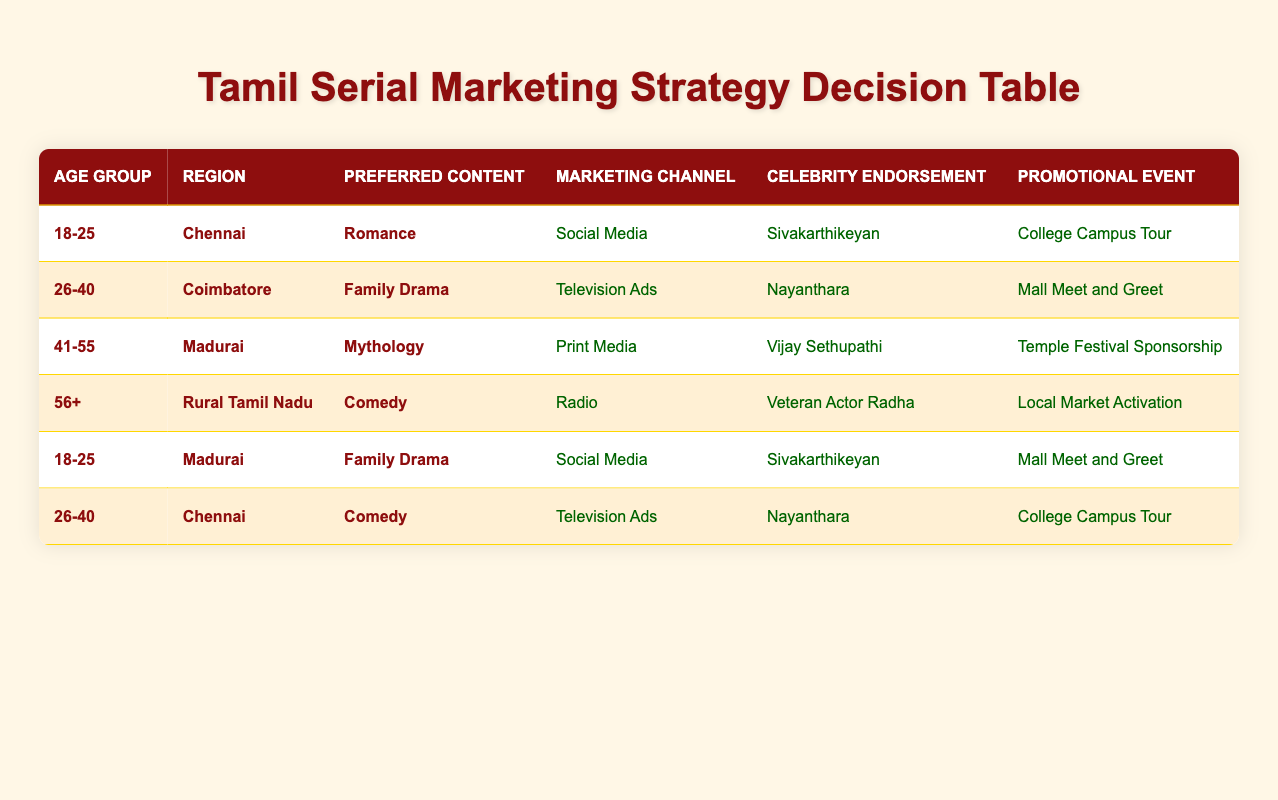What marketing channel is recommended for the 26-40 age group in Coimbatore? According to the table, for the 26-40 age group in Coimbatore, the recommended marketing channel is "Television Ads." This can be directly retrieved by locating the row that matches these conditions.
Answer: Television Ads Which celebrity endorsement is suggested for the 18-25 age group interested in romance in Chennai? The table indicates that for the 18-25 age group in Chennai, interested in romance, the suggested celebrity endorsement is "Sivakarthikeyan." This is found by referring to the appropriate row in the table.
Answer: Sivakarthikeyan Is print media recommended for promoting content preferred by the 41-55 age group in Madurai? Yes, print media is indeed recommended for promoting mythology, which is the preferred content of the 41-55 age group in Madurai, as per the data in the table.
Answer: Yes What is the promotional event planned for the 56+ age group in Rural Tamil Nadu who enjoys comedy? For the 56+ age group in Rural Tamil Nadu who prefers comedy, the promotional event is "Local Market Activation." This information is taken from the corresponding row in the table.
Answer: Local Market Activation How many different marketing channels are used for the 18-25 age group across both Chennai and Madurai? The 18-25 age group uses the marketing channel "Social Media" for both Chennai and Madurai; hence only one distinct channel is utilized. This is determined by reviewing the rows corresponding to the 18-25 age group in both regions.
Answer: 1 Are there any instances of Nayanthara being used for an event other than College Campus Tour? No, Nayanthara is only associated with "Mall Meet and Greet" for the 26-40 age group in Coimbatore and "College Campus Tour" for the 26-40 age group in Chennai. Thus, there are no other events linked to her endorsement based on the table.
Answer: No What is the promotional event for the 41-55 age group interested in mythology in Madurai? The table specifies that for the 41-55 age group interested in mythology, the promotional event is "Temple Festival Sponsorship." This is found within the row corresponding to these conditions.
Answer: Temple Festival Sponsorship Which combination of Marketing Channel, Celebrity Endorsement, and Promotional Event is unique to the 56+ age group? The unique combination for the 56+ age group is "Radio" for the marketing channel, "Veteran Actor Radha" for the celebrity endorsement, and "Local Market Activation" for the promotional event. This can be verified by looking specifically at the row for the 56+ age group.
Answer: Radio, Veteran Actor Radha, Local Market Activation 